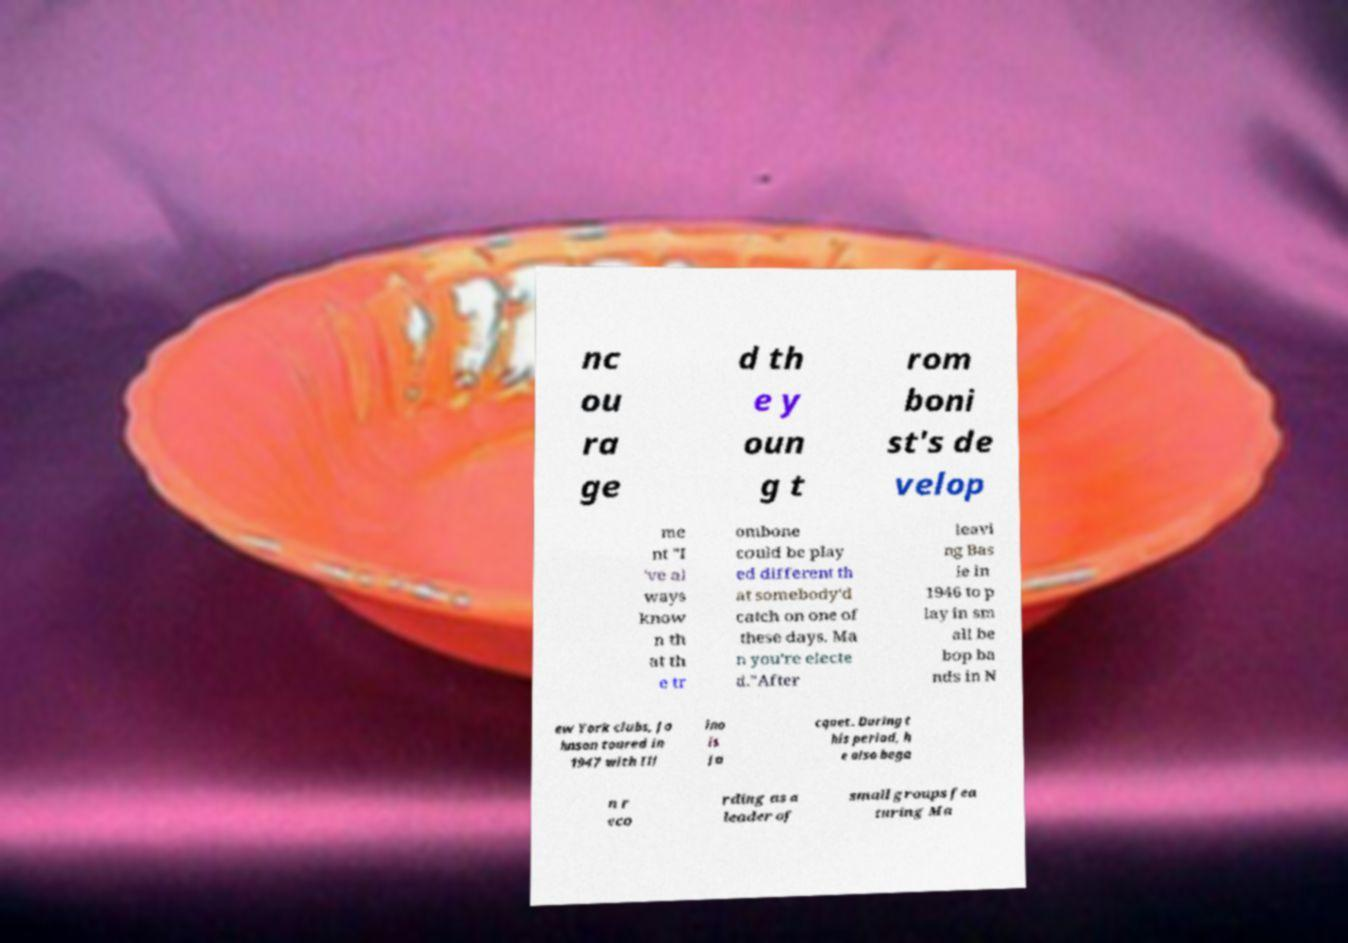Could you assist in decoding the text presented in this image and type it out clearly? nc ou ra ge d th e y oun g t rom boni st's de velop me nt "I 've al ways know n th at th e tr ombone could be play ed different th at somebody'd catch on one of these days. Ma n you're electe d."After leavi ng Bas ie in 1946 to p lay in sm all be bop ba nds in N ew York clubs, Jo hnson toured in 1947 with Ill ino is Ja cquet. During t his period, h e also bega n r eco rding as a leader of small groups fea turing Ma 